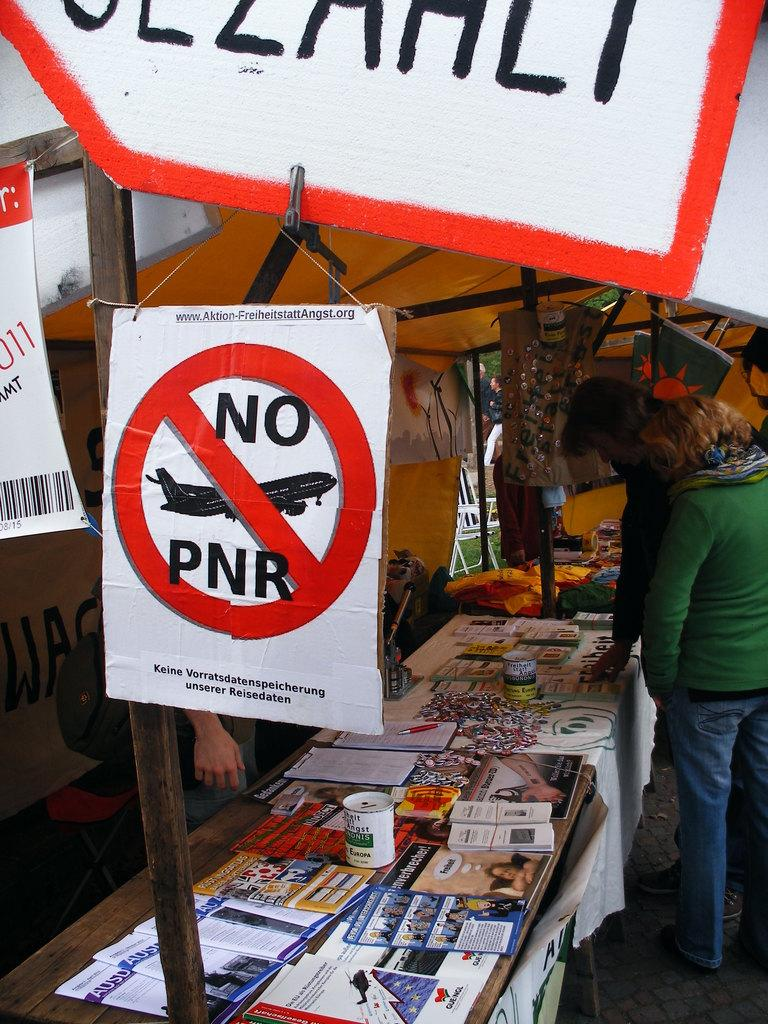<image>
Write a terse but informative summary of the picture. flea market stand of different periodicals with a sign that says NO PNR of an airplane. 